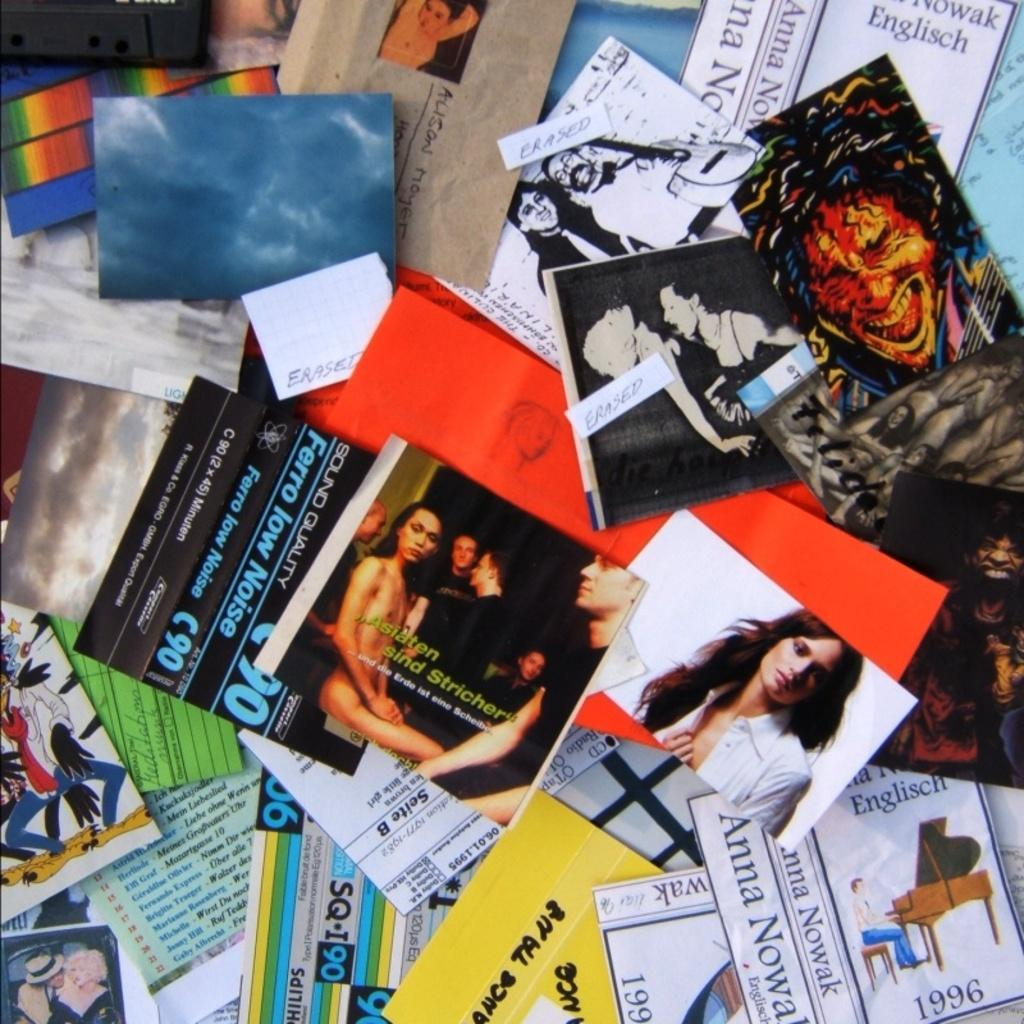<image>
Summarize the visual content of the image. Many cards on a table including one that has the name ANNA on it. 